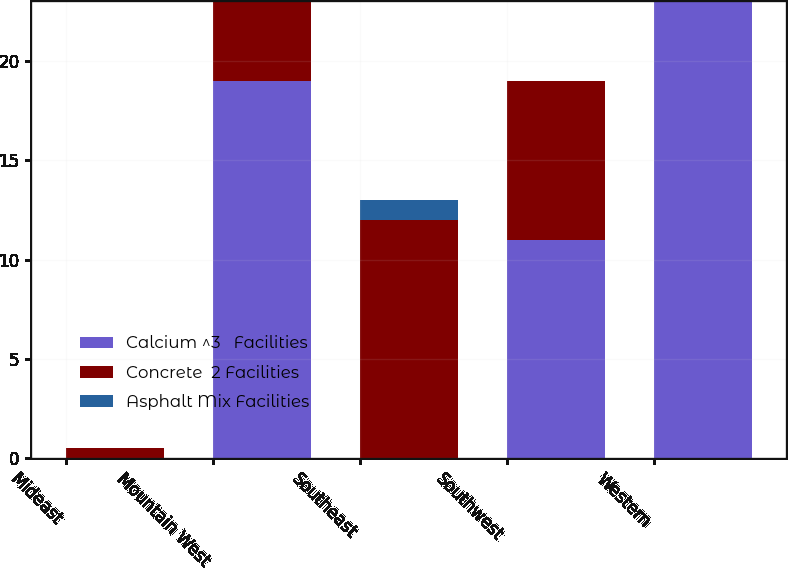Convert chart. <chart><loc_0><loc_0><loc_500><loc_500><stacked_bar_chart><ecel><fcel>Mideast<fcel>Mountain West<fcel>Southeast<fcel>Southwest<fcel>Western<nl><fcel>Calcium ^3   Facilities<fcel>0<fcel>19<fcel>0<fcel>11<fcel>23<nl><fcel>Concrete  2 Facilities<fcel>0.5<fcel>4<fcel>12<fcel>8<fcel>0<nl><fcel>Asphalt Mix Facilities<fcel>0<fcel>0<fcel>1<fcel>0<fcel>0<nl></chart> 